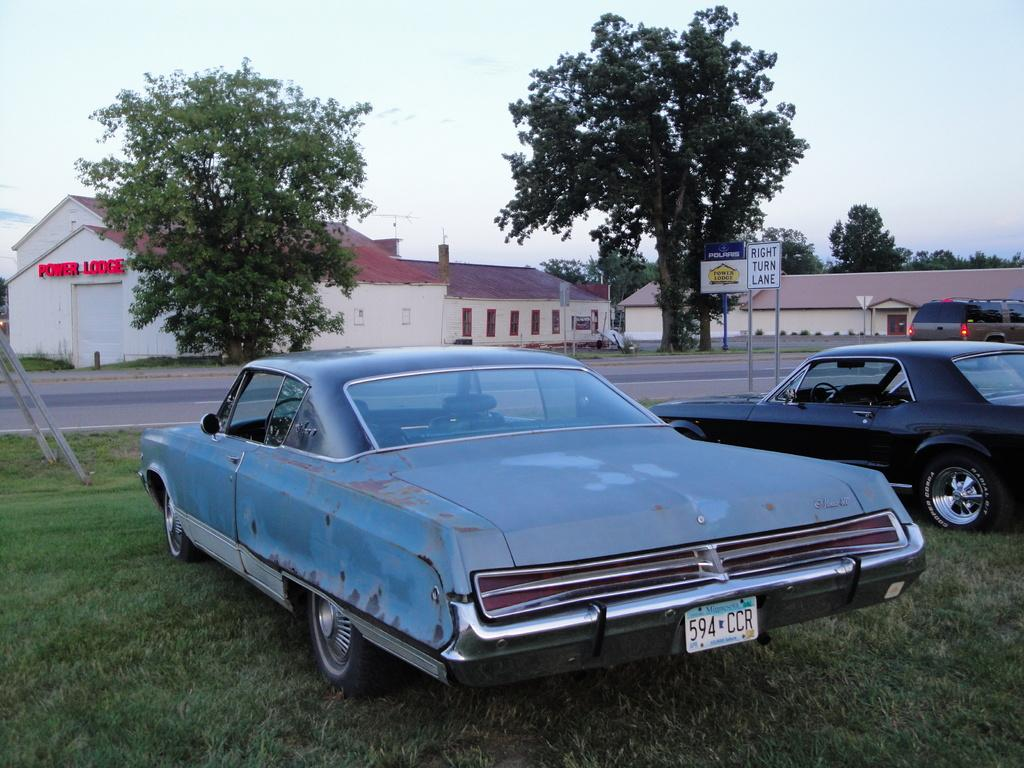What type of vehicles can be seen in the image? There are cars in the image. What type of structures are present in the image? There are houses in the image. What type of vegetation is visible in the image? There are trees in the image. What type of signage is present in the image? There are boards with text in the image. What type of ground cover is present in the image? There is grass on the ground in the image. What is the weather like in the image? The sky is cloudy in the image. What type of text is visible on a house in the image? There is text on the wall of a house in the image. Can you tell me how many loaves of bread are on the trail in the image? There is no trail or bread present in the image. What type of oil is being used to lubricate the cars in the image? There is no oil or indication of car maintenance in the image. 